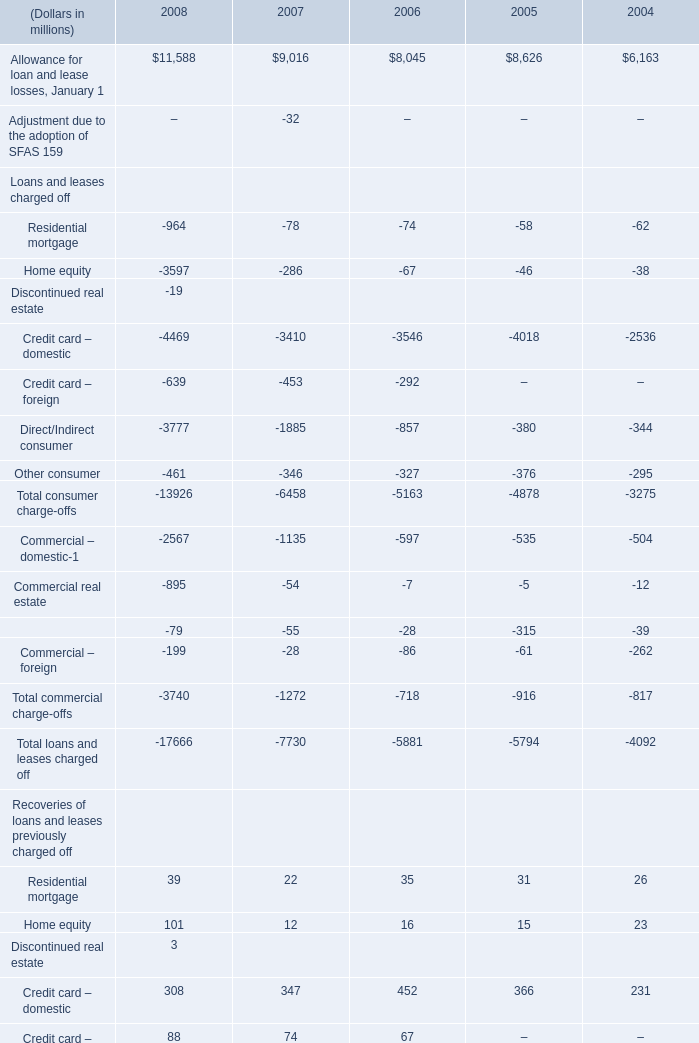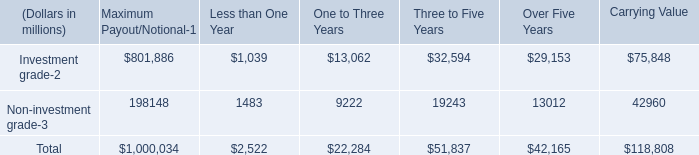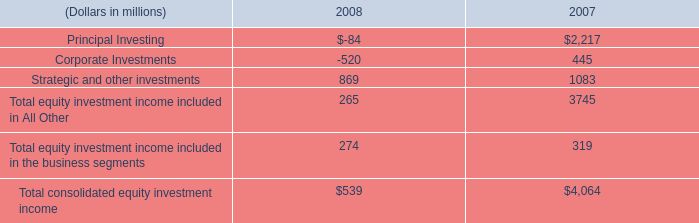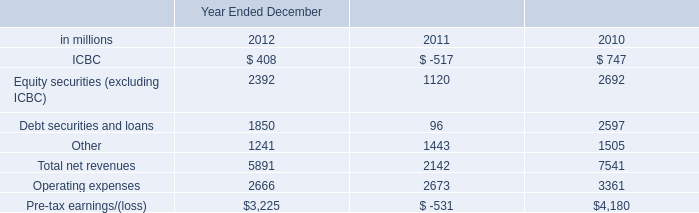what was the difference in net revenues in investing & lending in billions between 2012 and 2011? 
Computations: (5.89 - 2.14)
Answer: 3.75. 